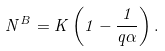Convert formula to latex. <formula><loc_0><loc_0><loc_500><loc_500>N ^ { B } = K \left ( 1 - \frac { 1 } { q \alpha } \right ) .</formula> 